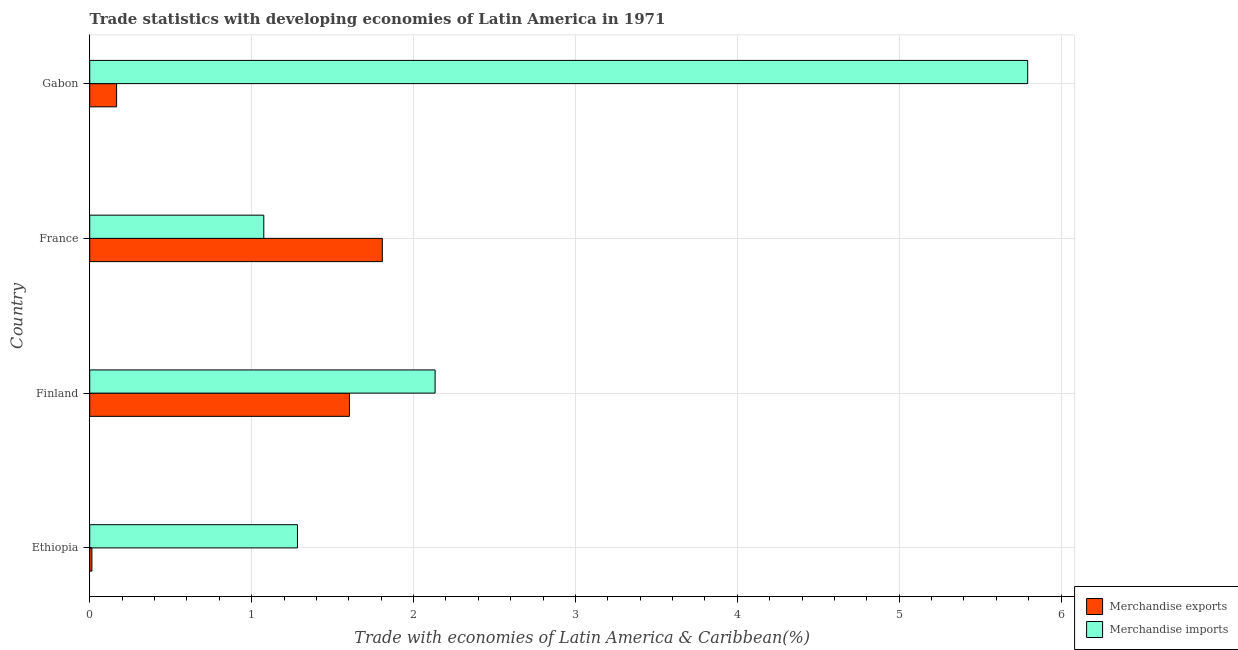How many groups of bars are there?
Give a very brief answer. 4. Are the number of bars on each tick of the Y-axis equal?
Offer a very short reply. Yes. How many bars are there on the 3rd tick from the top?
Provide a succinct answer. 2. In how many cases, is the number of bars for a given country not equal to the number of legend labels?
Make the answer very short. 0. What is the merchandise exports in Finland?
Offer a terse response. 1.6. Across all countries, what is the maximum merchandise exports?
Provide a short and direct response. 1.81. Across all countries, what is the minimum merchandise imports?
Offer a very short reply. 1.08. What is the total merchandise imports in the graph?
Ensure brevity in your answer.  10.29. What is the difference between the merchandise exports in Ethiopia and that in France?
Your answer should be very brief. -1.79. What is the difference between the merchandise imports in Ethiopia and the merchandise exports in Gabon?
Provide a short and direct response. 1.12. What is the average merchandise imports per country?
Give a very brief answer. 2.57. What is the difference between the merchandise imports and merchandise exports in France?
Give a very brief answer. -0.73. What is the ratio of the merchandise exports in Finland to that in France?
Offer a terse response. 0.89. Is the merchandise imports in Ethiopia less than that in France?
Keep it short and to the point. No. What is the difference between the highest and the second highest merchandise imports?
Your response must be concise. 3.66. What is the difference between the highest and the lowest merchandise exports?
Your response must be concise. 1.79. What does the 1st bar from the top in France represents?
Ensure brevity in your answer.  Merchandise imports. Are all the bars in the graph horizontal?
Your answer should be very brief. Yes. What is the difference between two consecutive major ticks on the X-axis?
Give a very brief answer. 1. Does the graph contain any zero values?
Provide a succinct answer. No. Does the graph contain grids?
Offer a terse response. Yes. How many legend labels are there?
Offer a very short reply. 2. How are the legend labels stacked?
Your answer should be very brief. Vertical. What is the title of the graph?
Provide a succinct answer. Trade statistics with developing economies of Latin America in 1971. Does "Primary income" appear as one of the legend labels in the graph?
Your response must be concise. No. What is the label or title of the X-axis?
Your answer should be compact. Trade with economies of Latin America & Caribbean(%). What is the Trade with economies of Latin America & Caribbean(%) in Merchandise exports in Ethiopia?
Ensure brevity in your answer.  0.01. What is the Trade with economies of Latin America & Caribbean(%) of Merchandise imports in Ethiopia?
Give a very brief answer. 1.28. What is the Trade with economies of Latin America & Caribbean(%) of Merchandise exports in Finland?
Your response must be concise. 1.6. What is the Trade with economies of Latin America & Caribbean(%) of Merchandise imports in Finland?
Make the answer very short. 2.13. What is the Trade with economies of Latin America & Caribbean(%) in Merchandise exports in France?
Provide a succinct answer. 1.81. What is the Trade with economies of Latin America & Caribbean(%) of Merchandise imports in France?
Your response must be concise. 1.08. What is the Trade with economies of Latin America & Caribbean(%) of Merchandise exports in Gabon?
Keep it short and to the point. 0.17. What is the Trade with economies of Latin America & Caribbean(%) of Merchandise imports in Gabon?
Ensure brevity in your answer.  5.79. Across all countries, what is the maximum Trade with economies of Latin America & Caribbean(%) in Merchandise exports?
Your answer should be compact. 1.81. Across all countries, what is the maximum Trade with economies of Latin America & Caribbean(%) of Merchandise imports?
Your answer should be compact. 5.79. Across all countries, what is the minimum Trade with economies of Latin America & Caribbean(%) in Merchandise exports?
Provide a short and direct response. 0.01. Across all countries, what is the minimum Trade with economies of Latin America & Caribbean(%) in Merchandise imports?
Your response must be concise. 1.08. What is the total Trade with economies of Latin America & Caribbean(%) of Merchandise exports in the graph?
Offer a very short reply. 3.59. What is the total Trade with economies of Latin America & Caribbean(%) in Merchandise imports in the graph?
Offer a very short reply. 10.29. What is the difference between the Trade with economies of Latin America & Caribbean(%) of Merchandise exports in Ethiopia and that in Finland?
Make the answer very short. -1.59. What is the difference between the Trade with economies of Latin America & Caribbean(%) of Merchandise imports in Ethiopia and that in Finland?
Provide a succinct answer. -0.85. What is the difference between the Trade with economies of Latin America & Caribbean(%) in Merchandise exports in Ethiopia and that in France?
Your response must be concise. -1.79. What is the difference between the Trade with economies of Latin America & Caribbean(%) in Merchandise imports in Ethiopia and that in France?
Give a very brief answer. 0.21. What is the difference between the Trade with economies of Latin America & Caribbean(%) of Merchandise exports in Ethiopia and that in Gabon?
Your response must be concise. -0.15. What is the difference between the Trade with economies of Latin America & Caribbean(%) in Merchandise imports in Ethiopia and that in Gabon?
Give a very brief answer. -4.51. What is the difference between the Trade with economies of Latin America & Caribbean(%) of Merchandise exports in Finland and that in France?
Provide a succinct answer. -0.2. What is the difference between the Trade with economies of Latin America & Caribbean(%) in Merchandise imports in Finland and that in France?
Offer a terse response. 1.06. What is the difference between the Trade with economies of Latin America & Caribbean(%) of Merchandise exports in Finland and that in Gabon?
Offer a terse response. 1.44. What is the difference between the Trade with economies of Latin America & Caribbean(%) in Merchandise imports in Finland and that in Gabon?
Provide a short and direct response. -3.66. What is the difference between the Trade with economies of Latin America & Caribbean(%) of Merchandise exports in France and that in Gabon?
Keep it short and to the point. 1.64. What is the difference between the Trade with economies of Latin America & Caribbean(%) of Merchandise imports in France and that in Gabon?
Provide a short and direct response. -4.72. What is the difference between the Trade with economies of Latin America & Caribbean(%) in Merchandise exports in Ethiopia and the Trade with economies of Latin America & Caribbean(%) in Merchandise imports in Finland?
Your answer should be very brief. -2.12. What is the difference between the Trade with economies of Latin America & Caribbean(%) of Merchandise exports in Ethiopia and the Trade with economies of Latin America & Caribbean(%) of Merchandise imports in France?
Keep it short and to the point. -1.06. What is the difference between the Trade with economies of Latin America & Caribbean(%) of Merchandise exports in Ethiopia and the Trade with economies of Latin America & Caribbean(%) of Merchandise imports in Gabon?
Give a very brief answer. -5.78. What is the difference between the Trade with economies of Latin America & Caribbean(%) in Merchandise exports in Finland and the Trade with economies of Latin America & Caribbean(%) in Merchandise imports in France?
Provide a succinct answer. 0.53. What is the difference between the Trade with economies of Latin America & Caribbean(%) of Merchandise exports in Finland and the Trade with economies of Latin America & Caribbean(%) of Merchandise imports in Gabon?
Provide a short and direct response. -4.19. What is the difference between the Trade with economies of Latin America & Caribbean(%) in Merchandise exports in France and the Trade with economies of Latin America & Caribbean(%) in Merchandise imports in Gabon?
Your answer should be compact. -3.99. What is the average Trade with economies of Latin America & Caribbean(%) of Merchandise exports per country?
Offer a terse response. 0.9. What is the average Trade with economies of Latin America & Caribbean(%) in Merchandise imports per country?
Provide a succinct answer. 2.57. What is the difference between the Trade with economies of Latin America & Caribbean(%) in Merchandise exports and Trade with economies of Latin America & Caribbean(%) in Merchandise imports in Ethiopia?
Provide a succinct answer. -1.27. What is the difference between the Trade with economies of Latin America & Caribbean(%) of Merchandise exports and Trade with economies of Latin America & Caribbean(%) of Merchandise imports in Finland?
Keep it short and to the point. -0.53. What is the difference between the Trade with economies of Latin America & Caribbean(%) in Merchandise exports and Trade with economies of Latin America & Caribbean(%) in Merchandise imports in France?
Give a very brief answer. 0.73. What is the difference between the Trade with economies of Latin America & Caribbean(%) of Merchandise exports and Trade with economies of Latin America & Caribbean(%) of Merchandise imports in Gabon?
Your response must be concise. -5.63. What is the ratio of the Trade with economies of Latin America & Caribbean(%) in Merchandise exports in Ethiopia to that in Finland?
Provide a short and direct response. 0.01. What is the ratio of the Trade with economies of Latin America & Caribbean(%) of Merchandise imports in Ethiopia to that in Finland?
Give a very brief answer. 0.6. What is the ratio of the Trade with economies of Latin America & Caribbean(%) of Merchandise exports in Ethiopia to that in France?
Your answer should be very brief. 0.01. What is the ratio of the Trade with economies of Latin America & Caribbean(%) of Merchandise imports in Ethiopia to that in France?
Keep it short and to the point. 1.19. What is the ratio of the Trade with economies of Latin America & Caribbean(%) in Merchandise exports in Ethiopia to that in Gabon?
Provide a succinct answer. 0.08. What is the ratio of the Trade with economies of Latin America & Caribbean(%) in Merchandise imports in Ethiopia to that in Gabon?
Make the answer very short. 0.22. What is the ratio of the Trade with economies of Latin America & Caribbean(%) in Merchandise exports in Finland to that in France?
Your answer should be very brief. 0.89. What is the ratio of the Trade with economies of Latin America & Caribbean(%) of Merchandise imports in Finland to that in France?
Your answer should be very brief. 1.98. What is the ratio of the Trade with economies of Latin America & Caribbean(%) of Merchandise exports in Finland to that in Gabon?
Your response must be concise. 9.66. What is the ratio of the Trade with economies of Latin America & Caribbean(%) of Merchandise imports in Finland to that in Gabon?
Keep it short and to the point. 0.37. What is the ratio of the Trade with economies of Latin America & Caribbean(%) in Merchandise exports in France to that in Gabon?
Provide a succinct answer. 10.88. What is the ratio of the Trade with economies of Latin America & Caribbean(%) of Merchandise imports in France to that in Gabon?
Your answer should be very brief. 0.19. What is the difference between the highest and the second highest Trade with economies of Latin America & Caribbean(%) in Merchandise exports?
Keep it short and to the point. 0.2. What is the difference between the highest and the second highest Trade with economies of Latin America & Caribbean(%) in Merchandise imports?
Your answer should be very brief. 3.66. What is the difference between the highest and the lowest Trade with economies of Latin America & Caribbean(%) of Merchandise exports?
Provide a succinct answer. 1.79. What is the difference between the highest and the lowest Trade with economies of Latin America & Caribbean(%) of Merchandise imports?
Give a very brief answer. 4.72. 